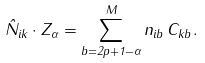<formula> <loc_0><loc_0><loc_500><loc_500>\hat { N } _ { i k } \cdot Z _ { \alpha } = \sum _ { b = 2 p + 1 - \alpha } ^ { M } n _ { i b } \, C _ { k b } \, .</formula> 